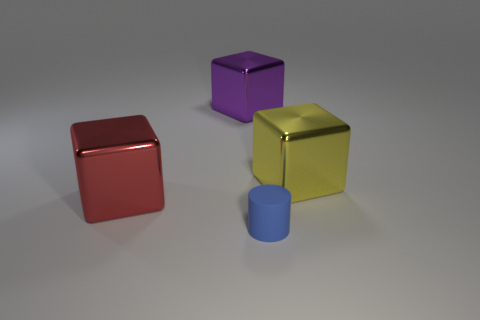Is there a block of the same size as the blue cylinder?
Ensure brevity in your answer.  No. There is a cube that is on the right side of the matte thing; is it the same size as the blue rubber thing?
Your answer should be compact. No. Are there more red objects than tiny gray metal cylinders?
Your response must be concise. Yes. Is there another object of the same shape as the large purple shiny thing?
Your answer should be compact. Yes. The thing right of the tiny blue matte thing has what shape?
Keep it short and to the point. Cube. What number of large purple shiny objects are to the right of the metallic block on the right side of the thing that is in front of the large red object?
Provide a succinct answer. 0. There is a large cube that is left of the purple thing; is it the same color as the small cylinder?
Ensure brevity in your answer.  No. What number of other things are there of the same shape as the blue thing?
Give a very brief answer. 0. How many other objects are the same material as the red block?
Offer a terse response. 2. There is a big yellow block behind the object that is in front of the big shiny thing in front of the yellow thing; what is it made of?
Provide a succinct answer. Metal. 